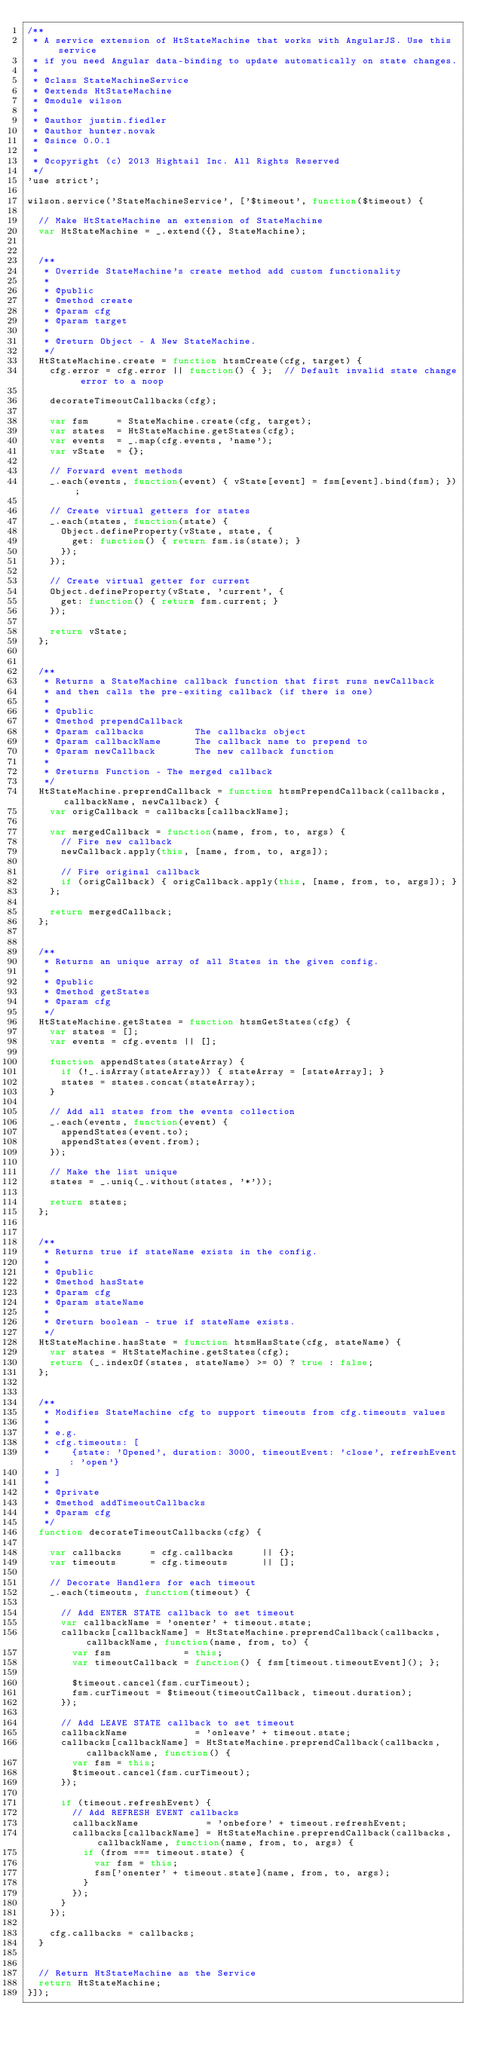<code> <loc_0><loc_0><loc_500><loc_500><_JavaScript_>/**
 * A service extension of HtStateMachine that works with AngularJS. Use this service
 * if you need Angular data-binding to update automatically on state changes.
 *
 * @class StateMachineService
 * @extends HtStateMachine
 * @module wilson
 *
 * @author justin.fiedler
 * @author hunter.novak
 * @since 0.0.1
 *
 * @copyright (c) 2013 Hightail Inc. All Rights Reserved
 */
'use strict';

wilson.service('StateMachineService', ['$timeout', function($timeout) {

  // Make HtStateMachine an extension of StateMachine
  var HtStateMachine = _.extend({}, StateMachine);


  /**
   * Override StateMachine's create method add custom functionality
   *
   * @public
   * @method create
   * @param cfg
   * @param target
   *
   * @return Object - A New StateMachine.
   */
  HtStateMachine.create = function htsmCreate(cfg, target) {
    cfg.error = cfg.error || function() { };  // Default invalid state change error to a noop

    decorateTimeoutCallbacks(cfg);

    var fsm     = StateMachine.create(cfg, target);
    var states  = HtStateMachine.getStates(cfg);
    var events  = _.map(cfg.events, 'name');
    var vState  = {};

    // Forward event methods
    _.each(events, function(event) { vState[event] = fsm[event].bind(fsm); });

    // Create virtual getters for states
    _.each(states, function(state) {
      Object.defineProperty(vState, state, {
        get: function() { return fsm.is(state); }
      });
    });

    // Create virtual getter for current
    Object.defineProperty(vState, 'current', {
      get: function() { return fsm.current; }
    });

    return vState;
  };


  /**
   * Returns a StateMachine callback function that first runs newCallback
   * and then calls the pre-exiting callback (if there is one)
   *
   * @public
   * @method prependCallback
   * @param callbacks         The callbacks object
   * @param callbackName      The callback name to prepend to
   * @param newCallback       The new callback function
   *
   * @returns Function - The merged callback
   */
  HtStateMachine.preprendCallback = function htsmPrependCallback(callbacks, callbackName, newCallback) {
    var origCallback = callbacks[callbackName];

    var mergedCallback = function(name, from, to, args) {
      // Fire new callback
      newCallback.apply(this, [name, from, to, args]);

      // Fire original callback
      if (origCallback) { origCallback.apply(this, [name, from, to, args]); }
    };

    return mergedCallback;
  };


  /**
   * Returns an unique array of all States in the given config.
   *
   * @public
   * @method getStates
   * @param cfg
   */
  HtStateMachine.getStates = function htsmGetStates(cfg) {
    var states = [];
    var events = cfg.events || [];

    function appendStates(stateArray) {
      if (!_.isArray(stateArray)) { stateArray = [stateArray]; }
      states = states.concat(stateArray);
    }

    // Add all states from the events collection
    _.each(events, function(event) {
      appendStates(event.to);
      appendStates(event.from);
    });

    // Make the list unique
    states = _.uniq(_.without(states, '*'));

    return states;
  };


  /**
   * Returns true if stateName exists in the config.
   *
   * @public
   * @method hasState
   * @param cfg
   * @param stateName
   *
   * @return boolean - true if stateName exists.
   */
  HtStateMachine.hasState = function htsmHasState(cfg, stateName) {
    var states = HtStateMachine.getStates(cfg);
    return (_.indexOf(states, stateName) >= 0) ? true : false;
  };


  /**
   * Modifies StateMachine cfg to support timeouts from cfg.timeouts values
   *
   * e.g.
   * cfg.timeouts: [
   *    {state: 'Opened', duration: 3000, timeoutEvent: 'close', refreshEvent: 'open'}
   * ]
   *
   * @private
   * @method addTimeoutCallbacks
   * @param cfg
   */
  function decorateTimeoutCallbacks(cfg) {

    var callbacks     = cfg.callbacks     || {};
    var timeouts      = cfg.timeouts      || [];

    // Decorate Handlers for each timeout
    _.each(timeouts, function(timeout) {

      // Add ENTER STATE callback to set timeout
      var callbackName = 'onenter' + timeout.state;
      callbacks[callbackName] = HtStateMachine.preprendCallback(callbacks, callbackName, function(name, from, to) {
        var fsm             = this;
        var timeoutCallback = function() { fsm[timeout.timeoutEvent](); };

        $timeout.cancel(fsm.curTimeout);
        fsm.curTimeout = $timeout(timeoutCallback, timeout.duration);
      });

      // Add LEAVE STATE callback to set timeout
      callbackName            = 'onleave' + timeout.state;
      callbacks[callbackName] = HtStateMachine.preprendCallback(callbacks, callbackName, function() {
        var fsm = this;
        $timeout.cancel(fsm.curTimeout);
      });

      if (timeout.refreshEvent) {
        // Add REFRESH EVENT callbacks
        callbackName            = 'onbefore' + timeout.refreshEvent;
        callbacks[callbackName] = HtStateMachine.preprendCallback(callbacks, callbackName, function(name, from, to, args) {
          if (from === timeout.state) {
            var fsm = this;
            fsm['onenter' + timeout.state](name, from, to, args);
          }
        });
      }
    });

    cfg.callbacks = callbacks;
  }


  // Return HtStateMachine as the Service
  return HtStateMachine;
}]);
</code> 